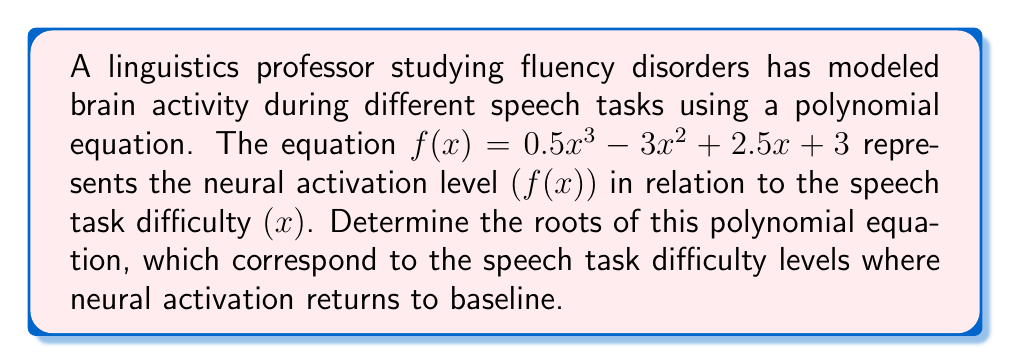Solve this math problem. To find the roots of the polynomial equation, we need to solve $f(x) = 0$:

$$0.5x^3 - 3x^2 + 2.5x + 3 = 0$$

1) First, let's check if there are any rational roots using the rational root theorem. The possible rational roots are the factors of the constant term (3): ±1, ±3.

2) Testing these values:
   $f(-3) = -40.5 \neq 0$
   $f(-1) = -3 \neq 0$
   $f(1) = 3 \neq 0$
   $f(3) = 0$

3) We've found one root: $x = 3$. We can factor this out:

   $$0.5x^3 - 3x^2 + 2.5x + 3 = 0.5(x - 3)(x^2 + ax + b) = 0$$

4) Expanding this and comparing coefficients:
   $$0.5x^3 - 3x^2 + 2.5x + 3 = 0.5x^3 + 0.5ax^2 + 0.5bx - 1.5x^2 - 1.5ax - 1.5b$$

   Comparing coefficients:
   $0.5a - 1.5 = -3$
   $0.5b - 1.5a = 2.5$
   $-1.5b = 3$

5) From the last equation: $b = -2$
   Substituting into the second equation: $-1 - 1.5a = 2.5$, so $a = -7/3$

6) Our quadratic factor is thus $x^2 - \frac{7}{3}x - 2$

7) We can solve this using the quadratic formula:
   $$x = \frac{-b \pm \sqrt{b^2 - 4ac}}{2a} = \frac{\frac{7}{3} \pm \sqrt{(\frac{7}{3})^2 - 4(1)(-2)}}{2(1)}$$
   $$= \frac{\frac{7}{3} \pm \sqrt{\frac{49}{9} + 8}}{2} = \frac{\frac{7}{3} \pm \sqrt{\frac{121}{9}}}{2} = \frac{\frac{7}{3} \pm \frac{11}{3}}{2}$$

8) This gives us the other two roots:
   $$x = \frac{\frac{7}{3} + \frac{11}{3}}{2} = 3$$ (which we already knew)
   $$x = \frac{\frac{7}{3} - \frac{11}{3}}{2} = -\frac{2}{3}$$
Answer: The roots of the polynomial equation are $x = -\frac{2}{3}$ and $x = 3$ (with multiplicity 2). 